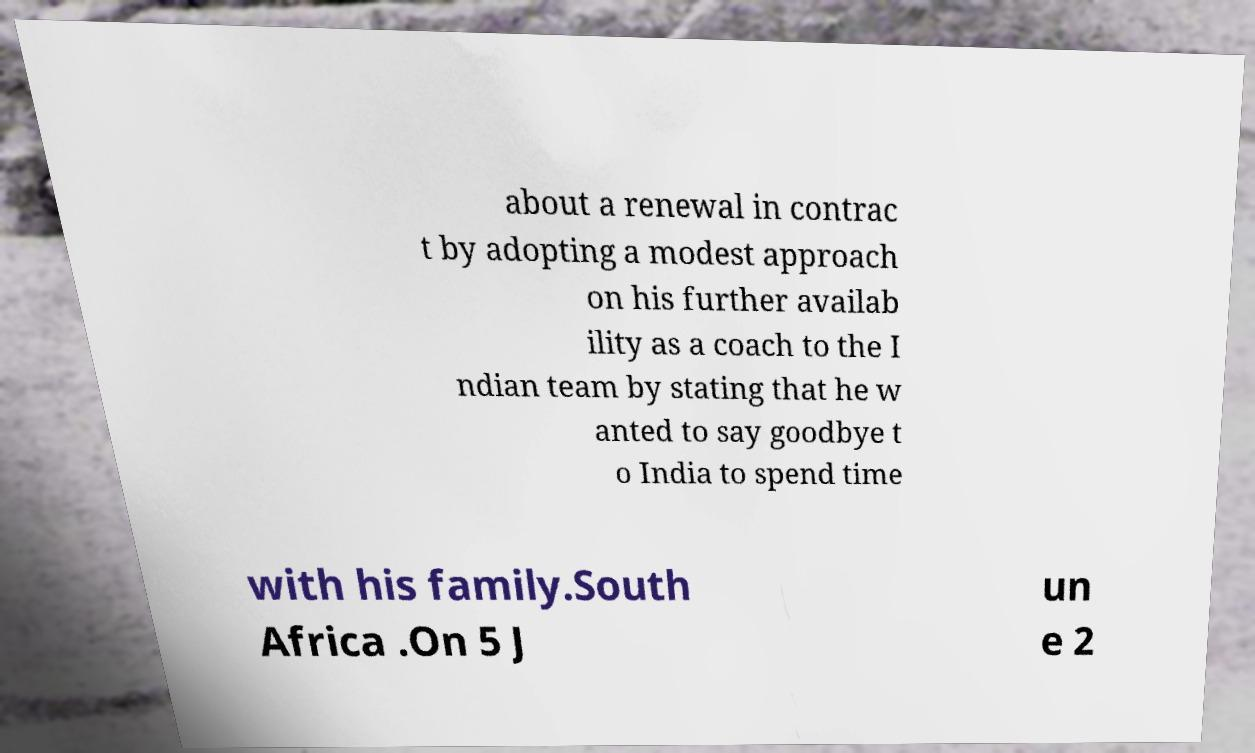There's text embedded in this image that I need extracted. Can you transcribe it verbatim? about a renewal in contrac t by adopting a modest approach on his further availab ility as a coach to the I ndian team by stating that he w anted to say goodbye t o India to spend time with his family.South Africa .On 5 J un e 2 